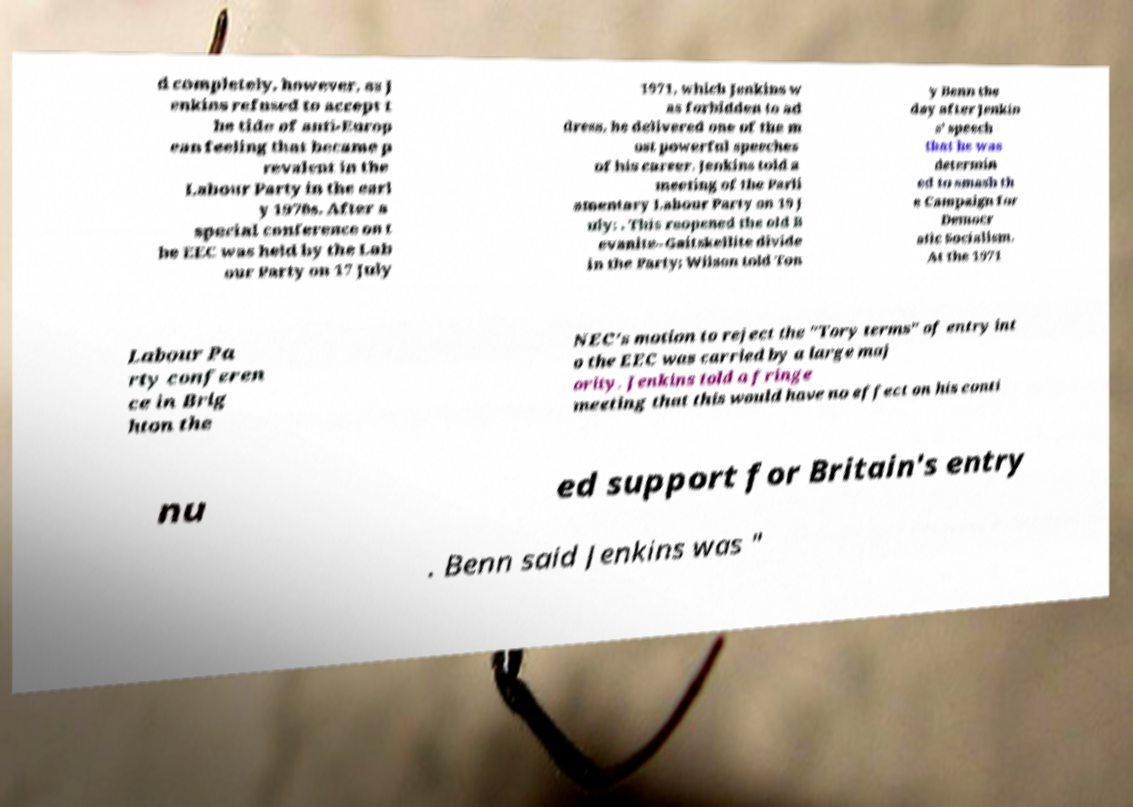Can you accurately transcribe the text from the provided image for me? d completely, however, as J enkins refused to accept t he tide of anti-Europ ean feeling that became p revalent in the Labour Party in the earl y 1970s. After a special conference on t he EEC was held by the Lab our Party on 17 July 1971, which Jenkins w as forbidden to ad dress, he delivered one of the m ost powerful speeches of his career. Jenkins told a meeting of the Parli amentary Labour Party on 19 J uly: . This reopened the old B evanite–Gaitskellite divide in the Party; Wilson told Ton y Benn the day after Jenkin s' speech that he was determin ed to smash th e Campaign for Democr atic Socialism. At the 1971 Labour Pa rty conferen ce in Brig hton the NEC's motion to reject the "Tory terms" of entry int o the EEC was carried by a large maj ority. Jenkins told a fringe meeting that this would have no effect on his conti nu ed support for Britain's entry . Benn said Jenkins was " 